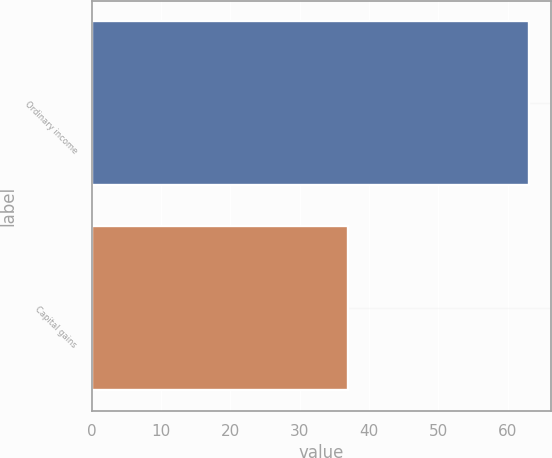<chart> <loc_0><loc_0><loc_500><loc_500><bar_chart><fcel>Ordinary income<fcel>Capital gains<nl><fcel>63.1<fcel>36.9<nl></chart> 